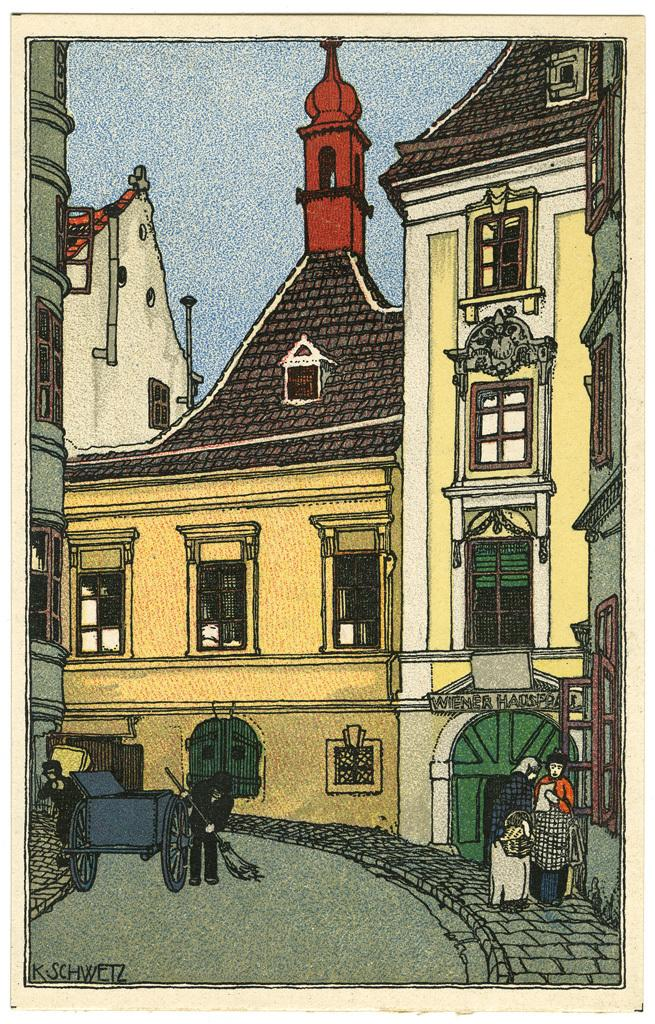What type of artwork is the image? The image is a painting. What subjects are depicted in the painting? There are paintings, a road, persons, and the sky depicted in the image. Can you describe the setting of the painting? The painting depicts a scene with a road and persons, as well as the sky. How many rings are visible on the road in the image? There are no rings depicted on the road in the image. What type of business is being conducted by the persons in the image? The image does not depict any business activities or transactions; it only shows a road, persons, and the sky. 